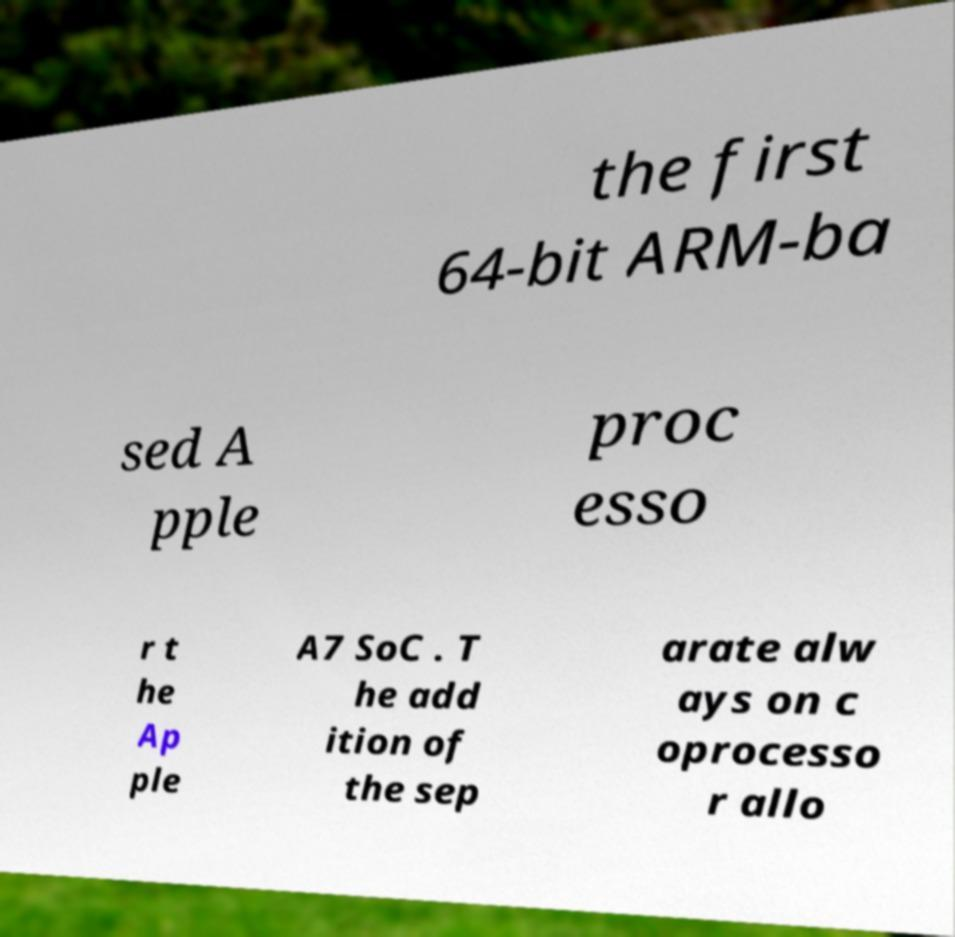Could you extract and type out the text from this image? the first 64-bit ARM-ba sed A pple proc esso r t he Ap ple A7 SoC . T he add ition of the sep arate alw ays on c oprocesso r allo 